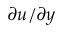<formula> <loc_0><loc_0><loc_500><loc_500>\partial u / \partial y</formula> 